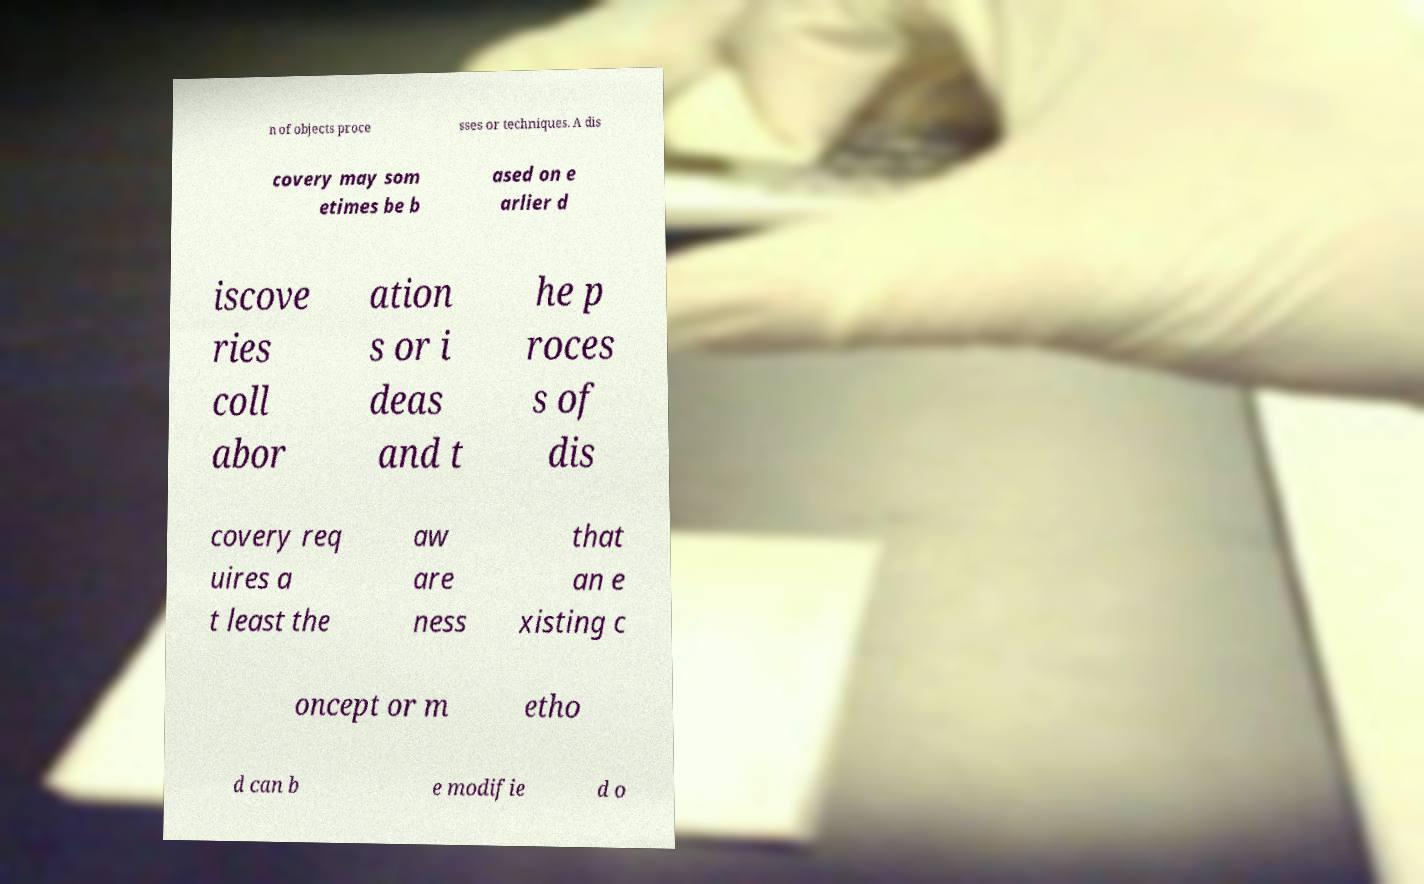Can you read and provide the text displayed in the image?This photo seems to have some interesting text. Can you extract and type it out for me? n of objects proce sses or techniques. A dis covery may som etimes be b ased on e arlier d iscove ries coll abor ation s or i deas and t he p roces s of dis covery req uires a t least the aw are ness that an e xisting c oncept or m etho d can b e modifie d o 